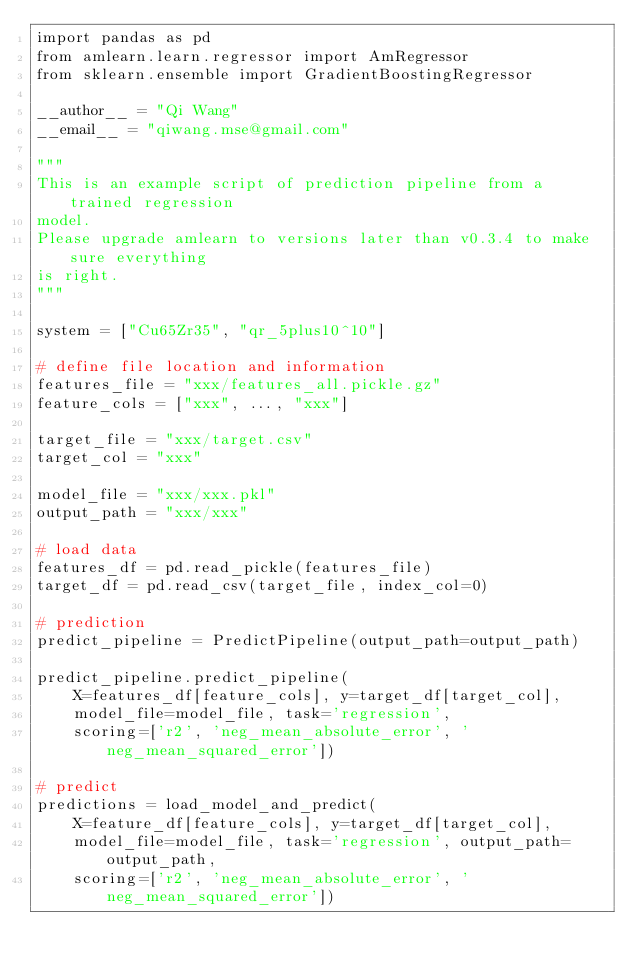<code> <loc_0><loc_0><loc_500><loc_500><_Python_>import pandas as pd
from amlearn.learn.regressor import AmRegressor
from sklearn.ensemble import GradientBoostingRegressor

__author__ = "Qi Wang"
__email__ = "qiwang.mse@gmail.com"

"""
This is an example script of prediction pipeline from a trained regression 
model.
Please upgrade amlearn to versions later than v0.3.4 to make sure everything
is right.
"""

system = ["Cu65Zr35", "qr_5plus10^10"]

# define file location and information
features_file = "xxx/features_all.pickle.gz"
feature_cols = ["xxx", ..., "xxx"]

target_file = "xxx/target.csv"
target_col = "xxx"

model_file = "xxx/xxx.pkl"
output_path = "xxx/xxx"

# load data
features_df = pd.read_pickle(features_file)
target_df = pd.read_csv(target_file, index_col=0)

# prediction
predict_pipeline = PredictPipeline(output_path=output_path)

predict_pipeline.predict_pipeline(
    X=features_df[feature_cols], y=target_df[target_col],
    model_file=model_file, task='regression',
    scoring=['r2', 'neg_mean_absolute_error', 'neg_mean_squared_error'])

# predict
predictions = load_model_and_predict(
    X=feature_df[feature_cols], y=target_df[target_col],
    model_file=model_file, task='regression', output_path=output_path,
    scoring=['r2', 'neg_mean_absolute_error', 'neg_mean_squared_error'])
</code> 